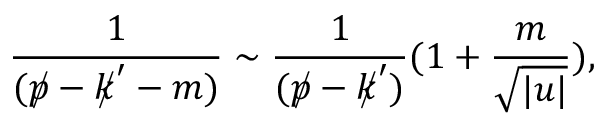Convert formula to latex. <formula><loc_0><loc_0><loc_500><loc_500>\frac { 1 } { ( p / - k / ^ { \prime } - m ) } \sim \frac { 1 } { ( p / - k / ^ { \prime } ) } ( 1 + \frac { m } { \sqrt { | u | } } ) ,</formula> 